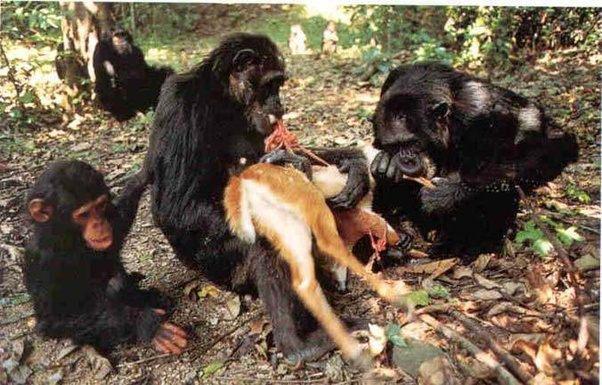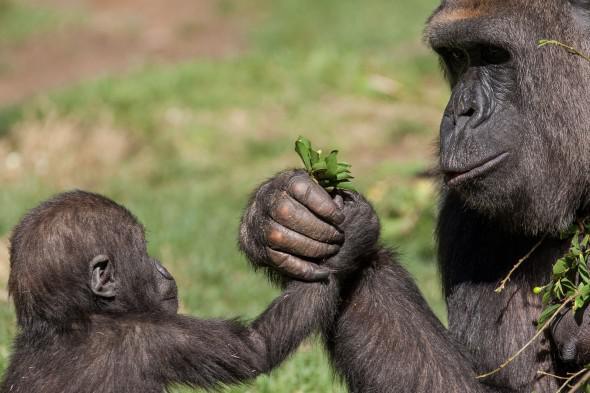The first image is the image on the left, the second image is the image on the right. Assess this claim about the two images: "The left image features an adult male gorilla clutching a leafy green item near its mouth.". Correct or not? Answer yes or no. No. The first image is the image on the left, the second image is the image on the right. Evaluate the accuracy of this statement regarding the images: "The right image contains two gorillas.". Is it true? Answer yes or no. Yes. 